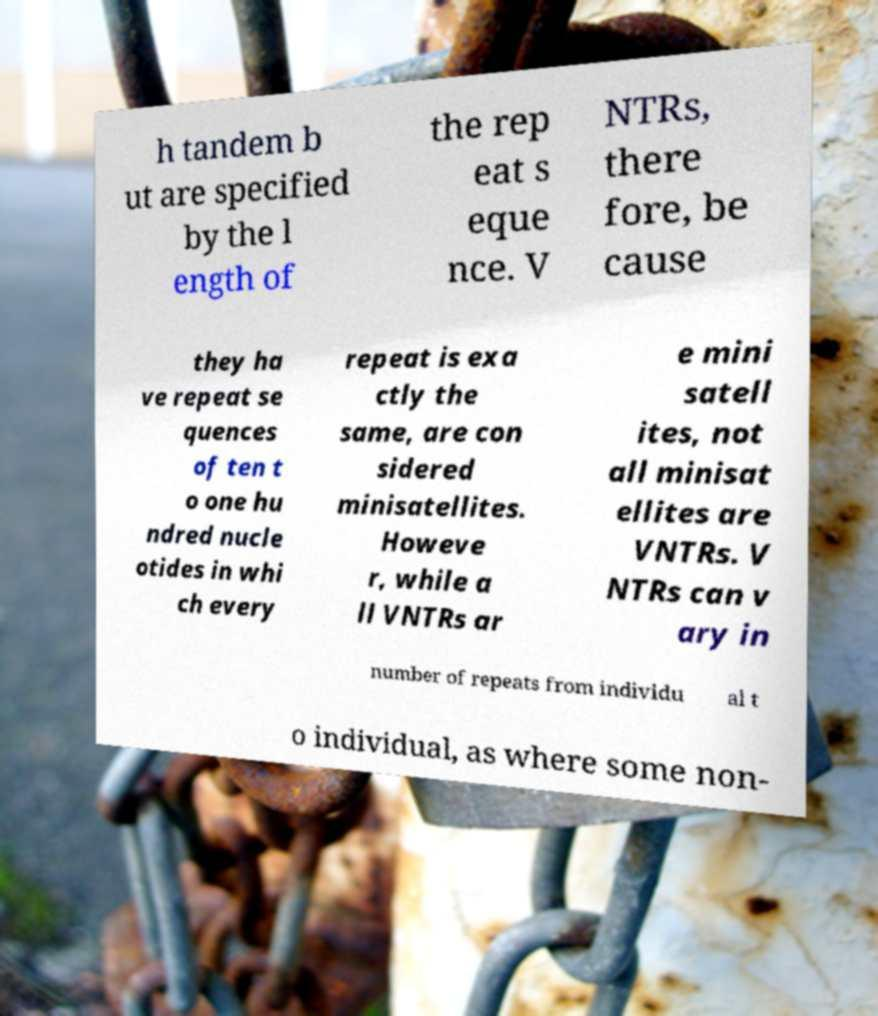For documentation purposes, I need the text within this image transcribed. Could you provide that? h tandem b ut are specified by the l ength of the rep eat s eque nce. V NTRs, there fore, be cause they ha ve repeat se quences of ten t o one hu ndred nucle otides in whi ch every repeat is exa ctly the same, are con sidered minisatellites. Howeve r, while a ll VNTRs ar e mini satell ites, not all minisat ellites are VNTRs. V NTRs can v ary in number of repeats from individu al t o individual, as where some non- 